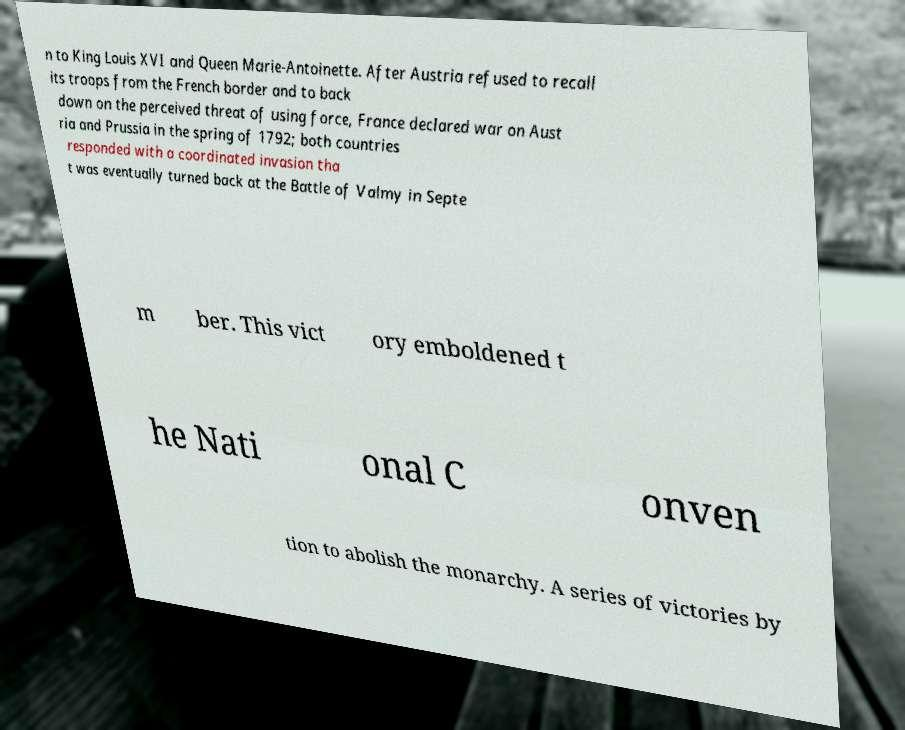Please identify and transcribe the text found in this image. n to King Louis XVI and Queen Marie-Antoinette. After Austria refused to recall its troops from the French border and to back down on the perceived threat of using force, France declared war on Aust ria and Prussia in the spring of 1792; both countries responded with a coordinated invasion tha t was eventually turned back at the Battle of Valmy in Septe m ber. This vict ory emboldened t he Nati onal C onven tion to abolish the monarchy. A series of victories by 